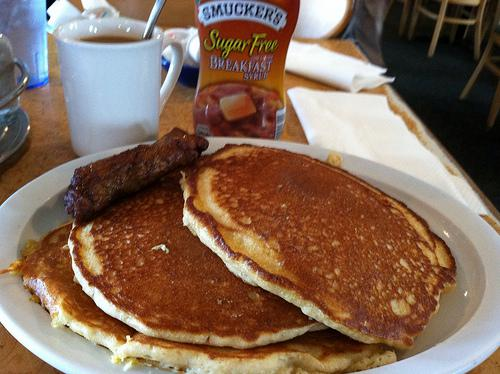Question: how many pancakes are there?
Choices:
A. Four.
B. Three.
C. Five.
D. Six.
Answer with the letter. Answer: B Question: where is this picture taken?
Choices:
A. At a museum.
B. By the local famous landmark.
C. At the zoo.
D. In a restaurant.
Answer with the letter. Answer: D Question: what is in the cup?
Choices:
A. Soda.
B. Water.
C. Milk.
D. Coffee.
Answer with the letter. Answer: D 